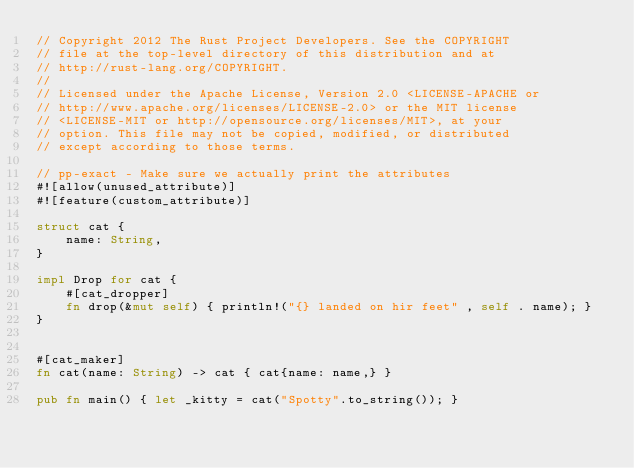Convert code to text. <code><loc_0><loc_0><loc_500><loc_500><_Rust_>// Copyright 2012 The Rust Project Developers. See the COPYRIGHT
// file at the top-level directory of this distribution and at
// http://rust-lang.org/COPYRIGHT.
//
// Licensed under the Apache License, Version 2.0 <LICENSE-APACHE or
// http://www.apache.org/licenses/LICENSE-2.0> or the MIT license
// <LICENSE-MIT or http://opensource.org/licenses/MIT>, at your
// option. This file may not be copied, modified, or distributed
// except according to those terms.

// pp-exact - Make sure we actually print the attributes
#![allow(unused_attribute)]
#![feature(custom_attribute)]

struct cat {
    name: String,
}

impl Drop for cat {
    #[cat_dropper]
    fn drop(&mut self) { println!("{} landed on hir feet" , self . name); }
}


#[cat_maker]
fn cat(name: String) -> cat { cat{name: name,} }

pub fn main() { let _kitty = cat("Spotty".to_string()); }
</code> 